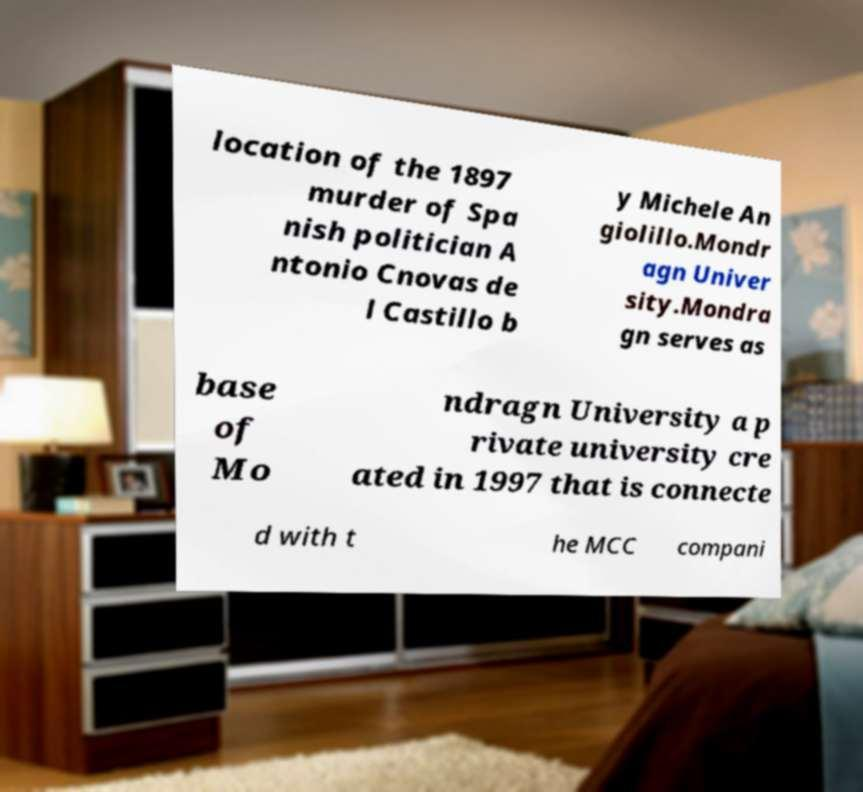Can you accurately transcribe the text from the provided image for me? location of the 1897 murder of Spa nish politician A ntonio Cnovas de l Castillo b y Michele An giolillo.Mondr agn Univer sity.Mondra gn serves as base of Mo ndragn University a p rivate university cre ated in 1997 that is connecte d with t he MCC compani 